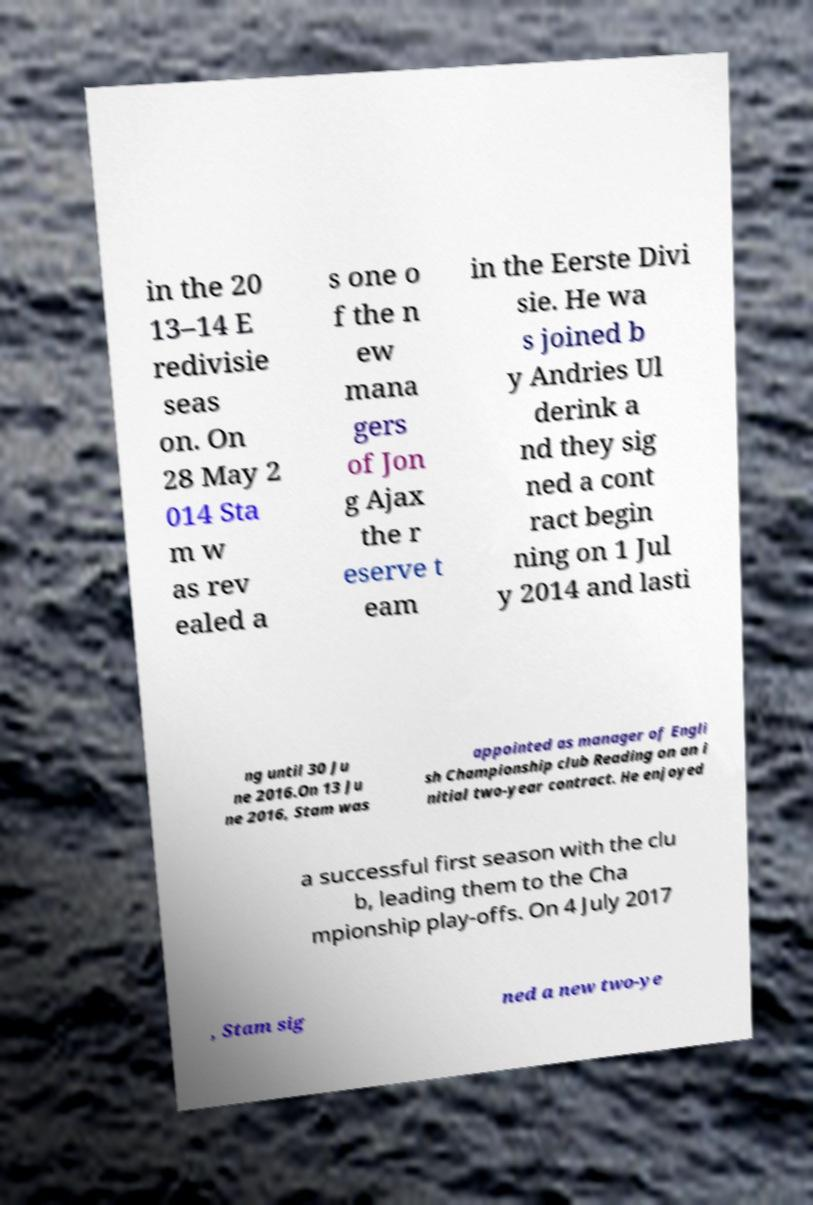There's text embedded in this image that I need extracted. Can you transcribe it verbatim? in the 20 13–14 E redivisie seas on. On 28 May 2 014 Sta m w as rev ealed a s one o f the n ew mana gers of Jon g Ajax the r eserve t eam in the Eerste Divi sie. He wa s joined b y Andries Ul derink a nd they sig ned a cont ract begin ning on 1 Jul y 2014 and lasti ng until 30 Ju ne 2016.On 13 Ju ne 2016, Stam was appointed as manager of Engli sh Championship club Reading on an i nitial two-year contract. He enjoyed a successful first season with the clu b, leading them to the Cha mpionship play-offs. On 4 July 2017 , Stam sig ned a new two-ye 